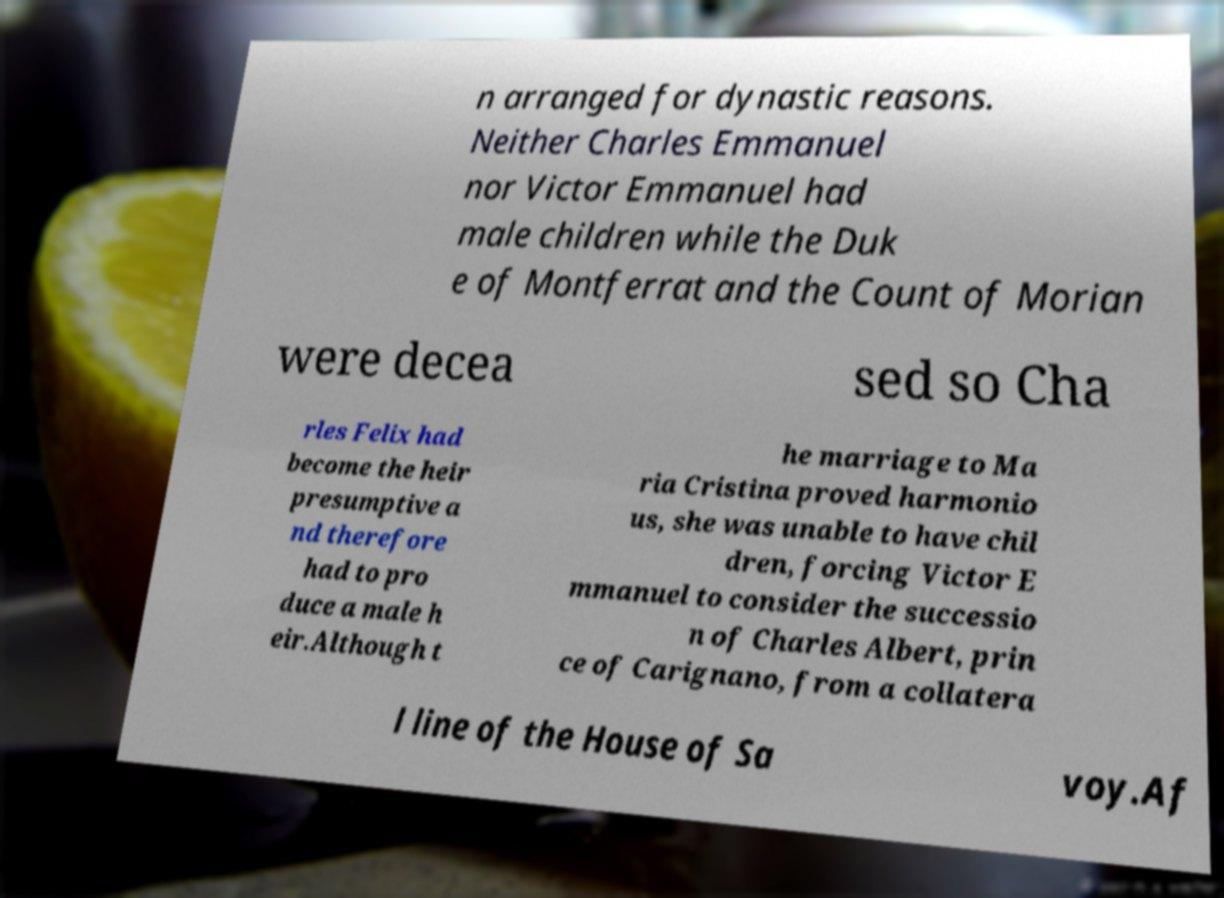Could you assist in decoding the text presented in this image and type it out clearly? n arranged for dynastic reasons. Neither Charles Emmanuel nor Victor Emmanuel had male children while the Duk e of Montferrat and the Count of Morian were decea sed so Cha rles Felix had become the heir presumptive a nd therefore had to pro duce a male h eir.Although t he marriage to Ma ria Cristina proved harmonio us, she was unable to have chil dren, forcing Victor E mmanuel to consider the successio n of Charles Albert, prin ce of Carignano, from a collatera l line of the House of Sa voy.Af 